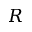<formula> <loc_0><loc_0><loc_500><loc_500>R</formula> 